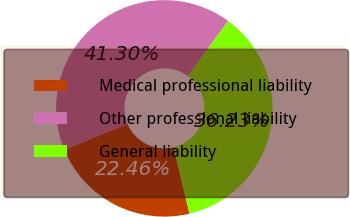Convert chart. <chart><loc_0><loc_0><loc_500><loc_500><pie_chart><fcel>Medical professional liability<fcel>Other professional liability<fcel>General liability<nl><fcel>22.46%<fcel>41.3%<fcel>36.23%<nl></chart> 